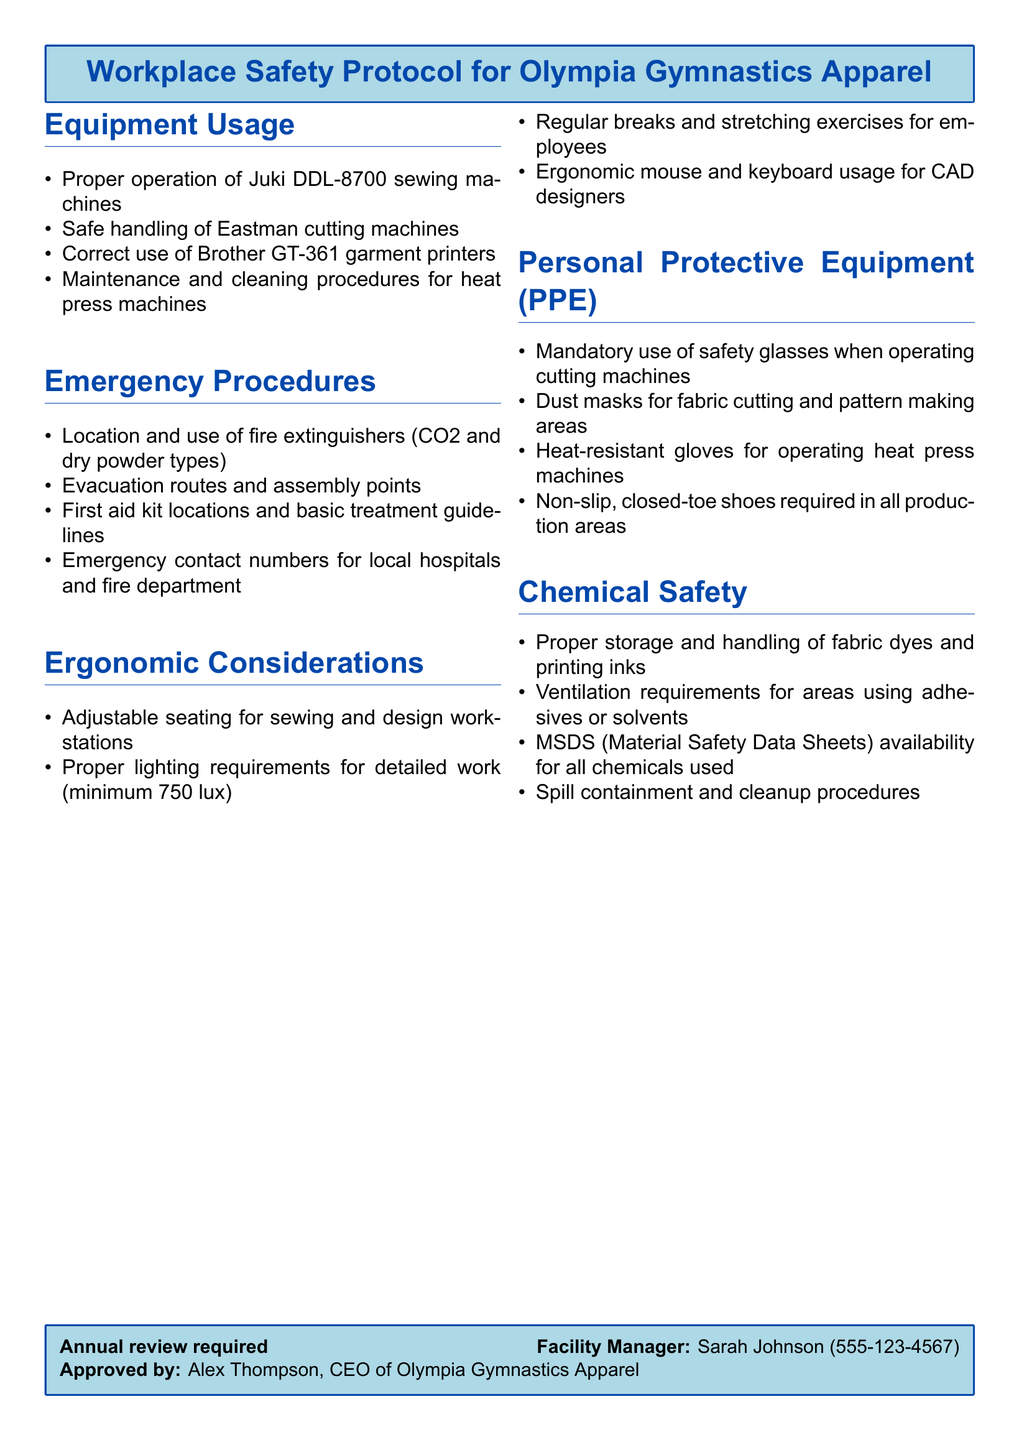What is the location of the first aid kit? The document lists the first aid kit locations under the Emergency Procedures section.
Answer: First aid kit locations What type of equipment requires safety glasses? The document specifies that safety glasses are mandatory when operating cutting machines under the Personal Protective Equipment section.
Answer: Cutting machines What should be the minimum lighting requirement for detailed work? The document states proper lighting requirements, specifying a minimum of 750 lux in the Ergonomic Considerations section.
Answer: 750 lux Who must review the workplace safety protocol annually? The document indicates that an annual review is required, mentioning the Facility Manager in the footer.
Answer: Facility Manager What are the evacuation routes and assembly points? The specific details about evacuation routes and assembly points are included in the Emergency Procedures section of the document.
Answer: Evacuation routes and assembly points Which gloves are required for operating heat press machines? The document mentions that heat-resistant gloves must be worn for this task, found in the Personal Protective Equipment section.
Answer: Heat-resistant gloves What is mandatory for the operation of fabric cutting and pattern making areas? The document states the requirement for dust masks in the Chemical Safety section.
Answer: Dust masks What are proper ergonomic practices mentioned in the document? The Ergonomic Considerations section lists practices like regular breaks and stretching exercises, adjusted seating, and proper lighting.
Answer: Regular breaks and stretching exercises What should be stored properly according to the Chemical Safety guidelines? The document states that fabric dyes and printing inks require proper storage and handling in the Chemical Safety section.
Answer: Fabric dyes and printing inks 